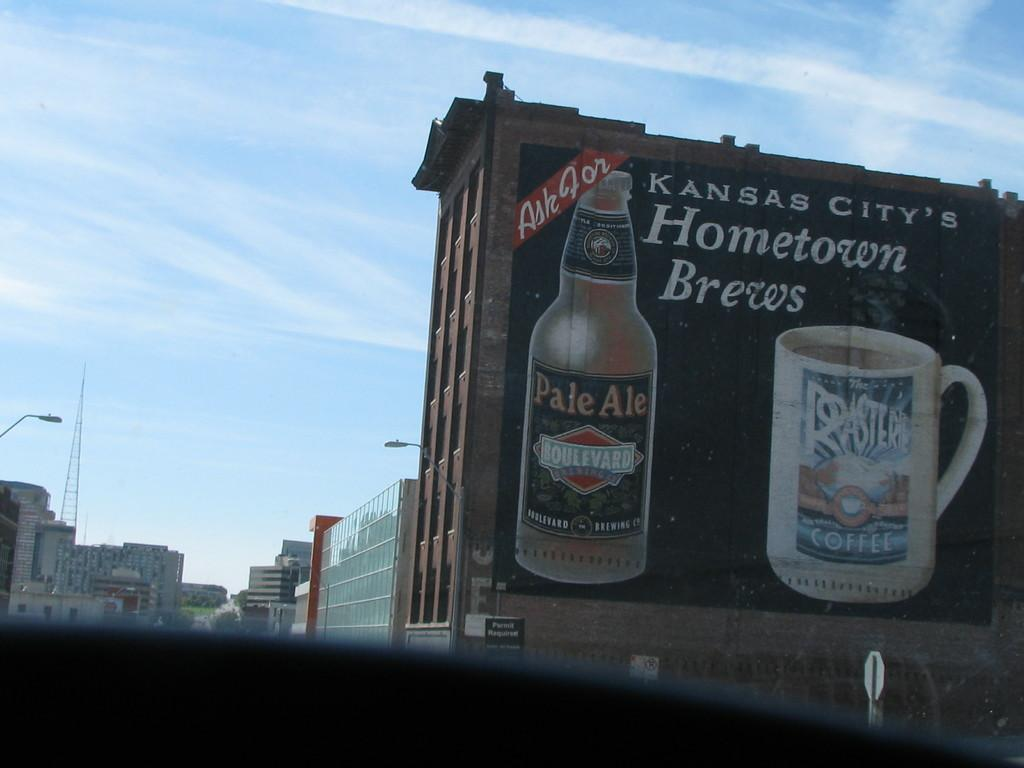<image>
Share a concise interpretation of the image provided. A large sign on the side of a building advertises Kansas City's Hometown Brews. 